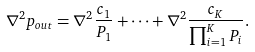<formula> <loc_0><loc_0><loc_500><loc_500>\nabla ^ { 2 } p _ { o u t } = \nabla ^ { 2 } \frac { c _ { 1 } } { P _ { 1 } } + \cdots + \nabla ^ { 2 } \frac { c _ { K } } { \prod _ { i = 1 } ^ { K } P _ { i } } .</formula> 